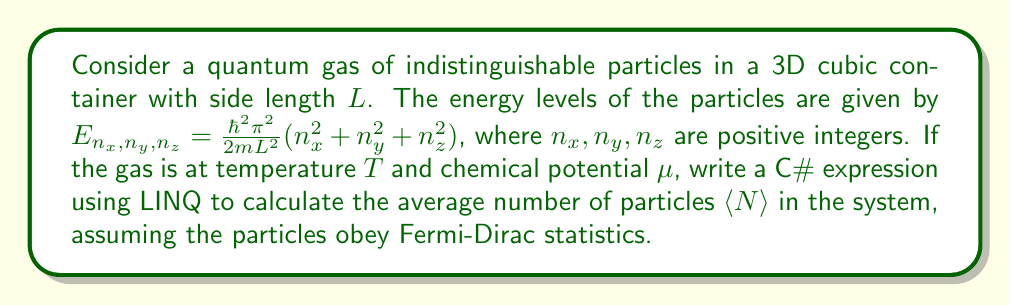Show me your answer to this math problem. To solve this problem, we'll follow these steps:

1) The average number of particles in a Fermi-Dirac system is given by:

   $$\langle N \rangle = \sum_{n_x,n_y,n_z} \frac{1}{e^{\beta(E_{n_x,n_y,n_z} - \mu)} + 1}$$

   where $\beta = \frac{1}{k_B T}$, and $k_B$ is the Boltzmann constant.

2) We need to sum over all possible combinations of $(n_x, n_y, n_z)$. In practice, we'll need to set an upper limit $N_{max}$ for each quantum number.

3) Let's define some constants:

   $$C = \frac{\hbar^2\pi^2}{2mL^2k_BT}$$

4) Now, we can rewrite the energy levels as:

   $$\beta E_{n_x,n_y,n_z} = C(n_x^2 + n_y^2 + n_z^2)$$

5) In C# with LINQ, we can represent this sum as:

```csharp
int Nmax = 100; // Choose an appropriate upper limit
double C = hbar * hbar * Math.PI * Math.PI / (2 * m * L * L * kB * T);
double betaMu = mu / (kB * T);

double avgN = Enumerable.Range(1, Nmax)
    .SelectMany(nx => Enumerable.Range(1, Nmax)
        .SelectMany(ny => Enumerable.Range(1, Nmax)
            .Select(nz => 1.0 / (Math.Exp(C * (nx*nx + ny*ny + nz*nz) - betaMu) + 1))))
    .Sum();
```

6) This LINQ expression generates all combinations of $(n_x, n_y, n_z)$ up to $N_{max}$, calculates the occupation number for each energy level, and sums them all.

7) The `SelectMany` method is used to flatten the nested loops into a single sequence, which is then summed using the `Sum` method.
Answer: ```csharp
Enumerable.Range(1, Nmax).SelectMany(nx => Enumerable.Range(1, Nmax).SelectMany(ny => Enumerable.Range(1, Nmax).Select(nz => 1.0 / (Math.Exp(C * (nx*nx + ny*ny + nz*nz) - betaMu) + 1)))).Sum();
``` 